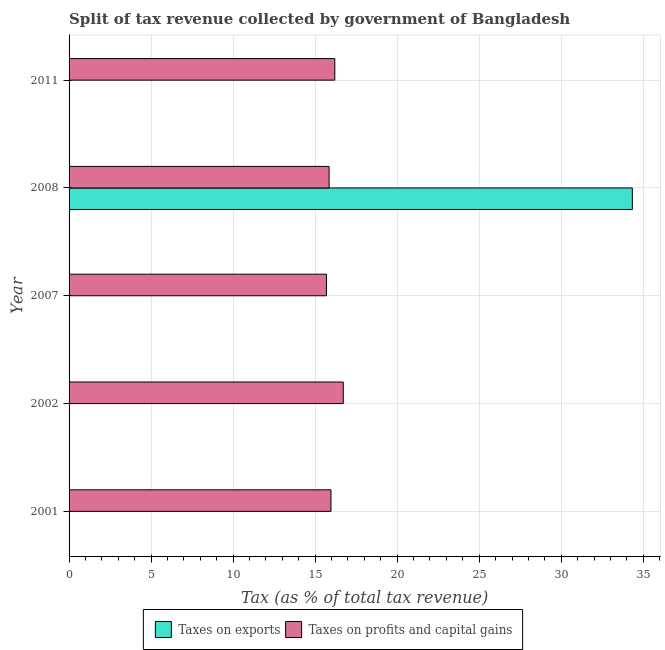How many groups of bars are there?
Ensure brevity in your answer.  5. Are the number of bars on each tick of the Y-axis equal?
Your answer should be compact. Yes. In how many cases, is the number of bars for a given year not equal to the number of legend labels?
Keep it short and to the point. 0. What is the percentage of revenue obtained from taxes on profits and capital gains in 2011?
Give a very brief answer. 16.2. Across all years, what is the maximum percentage of revenue obtained from taxes on profits and capital gains?
Ensure brevity in your answer.  16.72. Across all years, what is the minimum percentage of revenue obtained from taxes on exports?
Make the answer very short. 1.00567926439932e-6. In which year was the percentage of revenue obtained from taxes on profits and capital gains maximum?
Make the answer very short. 2002. In which year was the percentage of revenue obtained from taxes on profits and capital gains minimum?
Your answer should be compact. 2007. What is the total percentage of revenue obtained from taxes on exports in the graph?
Make the answer very short. 34.34. What is the difference between the percentage of revenue obtained from taxes on profits and capital gains in 2007 and that in 2011?
Provide a succinct answer. -0.51. What is the difference between the percentage of revenue obtained from taxes on profits and capital gains in 2007 and the percentage of revenue obtained from taxes on exports in 2001?
Provide a succinct answer. 15.69. What is the average percentage of revenue obtained from taxes on profits and capital gains per year?
Your response must be concise. 16.08. In the year 2008, what is the difference between the percentage of revenue obtained from taxes on profits and capital gains and percentage of revenue obtained from taxes on exports?
Make the answer very short. -18.48. What is the ratio of the percentage of revenue obtained from taxes on exports in 2002 to that in 2007?
Ensure brevity in your answer.  0.05. What is the difference between the highest and the second highest percentage of revenue obtained from taxes on exports?
Provide a short and direct response. 34.33. What is the difference between the highest and the lowest percentage of revenue obtained from taxes on profits and capital gains?
Ensure brevity in your answer.  1.03. Is the sum of the percentage of revenue obtained from taxes on exports in 2001 and 2011 greater than the maximum percentage of revenue obtained from taxes on profits and capital gains across all years?
Keep it short and to the point. No. What does the 1st bar from the top in 2011 represents?
Ensure brevity in your answer.  Taxes on profits and capital gains. What does the 2nd bar from the bottom in 2001 represents?
Offer a very short reply. Taxes on profits and capital gains. How many bars are there?
Offer a very short reply. 10. Are all the bars in the graph horizontal?
Offer a very short reply. Yes. How many years are there in the graph?
Make the answer very short. 5. Are the values on the major ticks of X-axis written in scientific E-notation?
Keep it short and to the point. No. Does the graph contain any zero values?
Your answer should be very brief. No. Does the graph contain grids?
Keep it short and to the point. Yes. Where does the legend appear in the graph?
Provide a succinct answer. Bottom center. How many legend labels are there?
Provide a short and direct response. 2. What is the title of the graph?
Offer a very short reply. Split of tax revenue collected by government of Bangladesh. Does "Investment in Transport" appear as one of the legend labels in the graph?
Offer a terse response. No. What is the label or title of the X-axis?
Ensure brevity in your answer.  Tax (as % of total tax revenue). What is the Tax (as % of total tax revenue) of Taxes on exports in 2001?
Ensure brevity in your answer.  0. What is the Tax (as % of total tax revenue) in Taxes on profits and capital gains in 2001?
Offer a terse response. 15.96. What is the Tax (as % of total tax revenue) of Taxes on exports in 2002?
Your answer should be very brief. 4.755177544301731e-6. What is the Tax (as % of total tax revenue) in Taxes on profits and capital gains in 2002?
Provide a succinct answer. 16.72. What is the Tax (as % of total tax revenue) in Taxes on exports in 2007?
Provide a succinct answer. 8.887465632262429e-5. What is the Tax (as % of total tax revenue) in Taxes on profits and capital gains in 2007?
Offer a very short reply. 15.69. What is the Tax (as % of total tax revenue) in Taxes on exports in 2008?
Your answer should be compact. 34.33. What is the Tax (as % of total tax revenue) in Taxes on profits and capital gains in 2008?
Your answer should be compact. 15.85. What is the Tax (as % of total tax revenue) of Taxes on exports in 2011?
Your response must be concise. 1.00567926439932e-6. What is the Tax (as % of total tax revenue) of Taxes on profits and capital gains in 2011?
Your response must be concise. 16.2. Across all years, what is the maximum Tax (as % of total tax revenue) of Taxes on exports?
Make the answer very short. 34.33. Across all years, what is the maximum Tax (as % of total tax revenue) in Taxes on profits and capital gains?
Give a very brief answer. 16.72. Across all years, what is the minimum Tax (as % of total tax revenue) of Taxes on exports?
Ensure brevity in your answer.  1.00567926439932e-6. Across all years, what is the minimum Tax (as % of total tax revenue) in Taxes on profits and capital gains?
Give a very brief answer. 15.69. What is the total Tax (as % of total tax revenue) in Taxes on exports in the graph?
Offer a terse response. 34.34. What is the total Tax (as % of total tax revenue) in Taxes on profits and capital gains in the graph?
Ensure brevity in your answer.  80.42. What is the difference between the Tax (as % of total tax revenue) in Taxes on exports in 2001 and that in 2002?
Offer a very short reply. 0. What is the difference between the Tax (as % of total tax revenue) of Taxes on profits and capital gains in 2001 and that in 2002?
Offer a terse response. -0.75. What is the difference between the Tax (as % of total tax revenue) in Taxes on exports in 2001 and that in 2007?
Give a very brief answer. 0. What is the difference between the Tax (as % of total tax revenue) in Taxes on profits and capital gains in 2001 and that in 2007?
Give a very brief answer. 0.28. What is the difference between the Tax (as % of total tax revenue) in Taxes on exports in 2001 and that in 2008?
Make the answer very short. -34.33. What is the difference between the Tax (as % of total tax revenue) in Taxes on profits and capital gains in 2001 and that in 2008?
Keep it short and to the point. 0.11. What is the difference between the Tax (as % of total tax revenue) of Taxes on exports in 2001 and that in 2011?
Your answer should be compact. 0. What is the difference between the Tax (as % of total tax revenue) in Taxes on profits and capital gains in 2001 and that in 2011?
Make the answer very short. -0.23. What is the difference between the Tax (as % of total tax revenue) in Taxes on exports in 2002 and that in 2007?
Make the answer very short. -0. What is the difference between the Tax (as % of total tax revenue) of Taxes on profits and capital gains in 2002 and that in 2007?
Provide a short and direct response. 1.03. What is the difference between the Tax (as % of total tax revenue) of Taxes on exports in 2002 and that in 2008?
Your answer should be compact. -34.33. What is the difference between the Tax (as % of total tax revenue) in Taxes on profits and capital gains in 2002 and that in 2008?
Your answer should be compact. 0.87. What is the difference between the Tax (as % of total tax revenue) of Taxes on profits and capital gains in 2002 and that in 2011?
Make the answer very short. 0.52. What is the difference between the Tax (as % of total tax revenue) in Taxes on exports in 2007 and that in 2008?
Provide a succinct answer. -34.33. What is the difference between the Tax (as % of total tax revenue) in Taxes on profits and capital gains in 2007 and that in 2008?
Your answer should be very brief. -0.16. What is the difference between the Tax (as % of total tax revenue) of Taxes on profits and capital gains in 2007 and that in 2011?
Provide a succinct answer. -0.51. What is the difference between the Tax (as % of total tax revenue) in Taxes on exports in 2008 and that in 2011?
Provide a short and direct response. 34.33. What is the difference between the Tax (as % of total tax revenue) of Taxes on profits and capital gains in 2008 and that in 2011?
Ensure brevity in your answer.  -0.35. What is the difference between the Tax (as % of total tax revenue) in Taxes on exports in 2001 and the Tax (as % of total tax revenue) in Taxes on profits and capital gains in 2002?
Offer a very short reply. -16.71. What is the difference between the Tax (as % of total tax revenue) in Taxes on exports in 2001 and the Tax (as % of total tax revenue) in Taxes on profits and capital gains in 2007?
Ensure brevity in your answer.  -15.69. What is the difference between the Tax (as % of total tax revenue) of Taxes on exports in 2001 and the Tax (as % of total tax revenue) of Taxes on profits and capital gains in 2008?
Give a very brief answer. -15.85. What is the difference between the Tax (as % of total tax revenue) of Taxes on exports in 2001 and the Tax (as % of total tax revenue) of Taxes on profits and capital gains in 2011?
Ensure brevity in your answer.  -16.2. What is the difference between the Tax (as % of total tax revenue) in Taxes on exports in 2002 and the Tax (as % of total tax revenue) in Taxes on profits and capital gains in 2007?
Provide a short and direct response. -15.69. What is the difference between the Tax (as % of total tax revenue) in Taxes on exports in 2002 and the Tax (as % of total tax revenue) in Taxes on profits and capital gains in 2008?
Offer a terse response. -15.85. What is the difference between the Tax (as % of total tax revenue) of Taxes on exports in 2002 and the Tax (as % of total tax revenue) of Taxes on profits and capital gains in 2011?
Your answer should be compact. -16.2. What is the difference between the Tax (as % of total tax revenue) in Taxes on exports in 2007 and the Tax (as % of total tax revenue) in Taxes on profits and capital gains in 2008?
Your response must be concise. -15.85. What is the difference between the Tax (as % of total tax revenue) of Taxes on exports in 2007 and the Tax (as % of total tax revenue) of Taxes on profits and capital gains in 2011?
Give a very brief answer. -16.2. What is the difference between the Tax (as % of total tax revenue) in Taxes on exports in 2008 and the Tax (as % of total tax revenue) in Taxes on profits and capital gains in 2011?
Your answer should be very brief. 18.14. What is the average Tax (as % of total tax revenue) in Taxes on exports per year?
Your answer should be very brief. 6.87. What is the average Tax (as % of total tax revenue) in Taxes on profits and capital gains per year?
Give a very brief answer. 16.08. In the year 2001, what is the difference between the Tax (as % of total tax revenue) in Taxes on exports and Tax (as % of total tax revenue) in Taxes on profits and capital gains?
Your answer should be very brief. -15.96. In the year 2002, what is the difference between the Tax (as % of total tax revenue) in Taxes on exports and Tax (as % of total tax revenue) in Taxes on profits and capital gains?
Provide a succinct answer. -16.72. In the year 2007, what is the difference between the Tax (as % of total tax revenue) in Taxes on exports and Tax (as % of total tax revenue) in Taxes on profits and capital gains?
Provide a succinct answer. -15.69. In the year 2008, what is the difference between the Tax (as % of total tax revenue) in Taxes on exports and Tax (as % of total tax revenue) in Taxes on profits and capital gains?
Your answer should be very brief. 18.48. In the year 2011, what is the difference between the Tax (as % of total tax revenue) in Taxes on exports and Tax (as % of total tax revenue) in Taxes on profits and capital gains?
Your response must be concise. -16.2. What is the ratio of the Tax (as % of total tax revenue) of Taxes on exports in 2001 to that in 2002?
Keep it short and to the point. 274.05. What is the ratio of the Tax (as % of total tax revenue) in Taxes on profits and capital gains in 2001 to that in 2002?
Offer a very short reply. 0.96. What is the ratio of the Tax (as % of total tax revenue) of Taxes on exports in 2001 to that in 2007?
Your answer should be compact. 14.66. What is the ratio of the Tax (as % of total tax revenue) of Taxes on profits and capital gains in 2001 to that in 2007?
Provide a succinct answer. 1.02. What is the ratio of the Tax (as % of total tax revenue) in Taxes on exports in 2001 to that in 2008?
Your response must be concise. 0. What is the ratio of the Tax (as % of total tax revenue) in Taxes on exports in 2001 to that in 2011?
Ensure brevity in your answer.  1295.81. What is the ratio of the Tax (as % of total tax revenue) in Taxes on profits and capital gains in 2001 to that in 2011?
Your answer should be compact. 0.99. What is the ratio of the Tax (as % of total tax revenue) of Taxes on exports in 2002 to that in 2007?
Offer a terse response. 0.05. What is the ratio of the Tax (as % of total tax revenue) of Taxes on profits and capital gains in 2002 to that in 2007?
Give a very brief answer. 1.07. What is the ratio of the Tax (as % of total tax revenue) in Taxes on exports in 2002 to that in 2008?
Offer a very short reply. 0. What is the ratio of the Tax (as % of total tax revenue) of Taxes on profits and capital gains in 2002 to that in 2008?
Offer a very short reply. 1.05. What is the ratio of the Tax (as % of total tax revenue) in Taxes on exports in 2002 to that in 2011?
Offer a terse response. 4.73. What is the ratio of the Tax (as % of total tax revenue) of Taxes on profits and capital gains in 2002 to that in 2011?
Keep it short and to the point. 1.03. What is the ratio of the Tax (as % of total tax revenue) of Taxes on profits and capital gains in 2007 to that in 2008?
Provide a succinct answer. 0.99. What is the ratio of the Tax (as % of total tax revenue) of Taxes on exports in 2007 to that in 2011?
Make the answer very short. 88.37. What is the ratio of the Tax (as % of total tax revenue) in Taxes on profits and capital gains in 2007 to that in 2011?
Your response must be concise. 0.97. What is the ratio of the Tax (as % of total tax revenue) in Taxes on exports in 2008 to that in 2011?
Provide a succinct answer. 3.41e+07. What is the ratio of the Tax (as % of total tax revenue) of Taxes on profits and capital gains in 2008 to that in 2011?
Your response must be concise. 0.98. What is the difference between the highest and the second highest Tax (as % of total tax revenue) in Taxes on exports?
Ensure brevity in your answer.  34.33. What is the difference between the highest and the second highest Tax (as % of total tax revenue) of Taxes on profits and capital gains?
Provide a succinct answer. 0.52. What is the difference between the highest and the lowest Tax (as % of total tax revenue) in Taxes on exports?
Your answer should be compact. 34.33. What is the difference between the highest and the lowest Tax (as % of total tax revenue) of Taxes on profits and capital gains?
Make the answer very short. 1.03. 